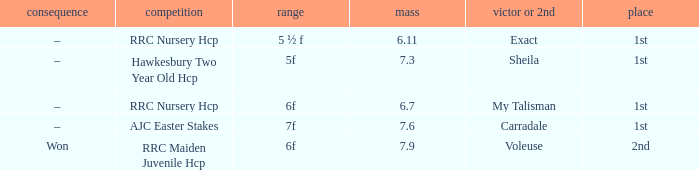What was the name of the winner or 2nd when the result was –, and weight was 6.7? My Talisman. 